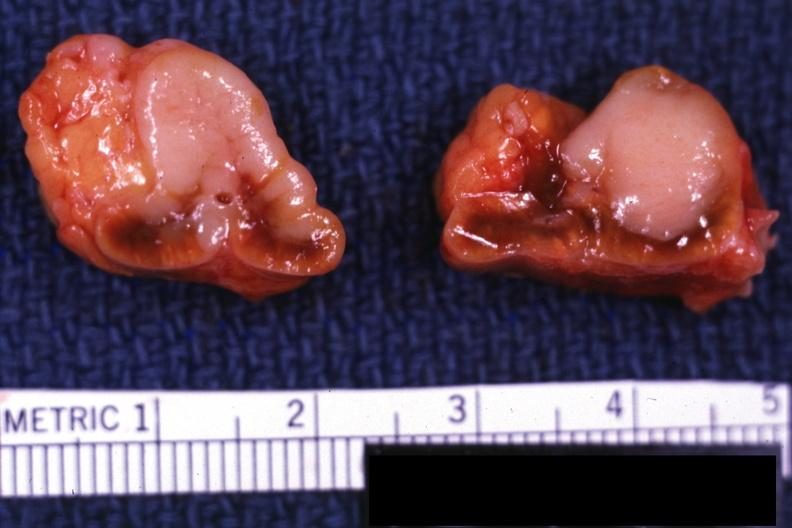s metastatic carcinoma present?
Answer the question using a single word or phrase. Yes 